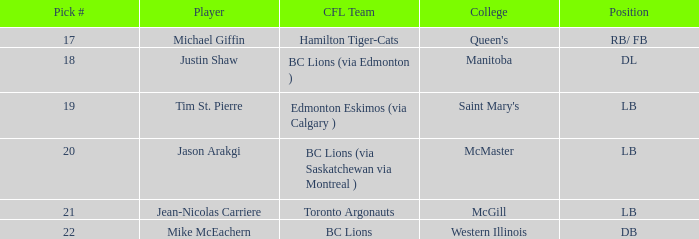How many pick numbers did Michael Giffin have? 1.0. Parse the table in full. {'header': ['Pick #', 'Player', 'CFL Team', 'College', 'Position'], 'rows': [['17', 'Michael Giffin', 'Hamilton Tiger-Cats', "Queen's", 'RB/ FB'], ['18', 'Justin Shaw', 'BC Lions (via Edmonton )', 'Manitoba', 'DL'], ['19', 'Tim St. Pierre', 'Edmonton Eskimos (via Calgary )', "Saint Mary's", 'LB'], ['20', 'Jason Arakgi', 'BC Lions (via Saskatchewan via Montreal )', 'McMaster', 'LB'], ['21', 'Jean-Nicolas Carriere', 'Toronto Argonauts', 'McGill', 'LB'], ['22', 'Mike McEachern', 'BC Lions', 'Western Illinois', 'DB']]} 